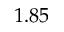<formula> <loc_0><loc_0><loc_500><loc_500>1 . 8 5</formula> 